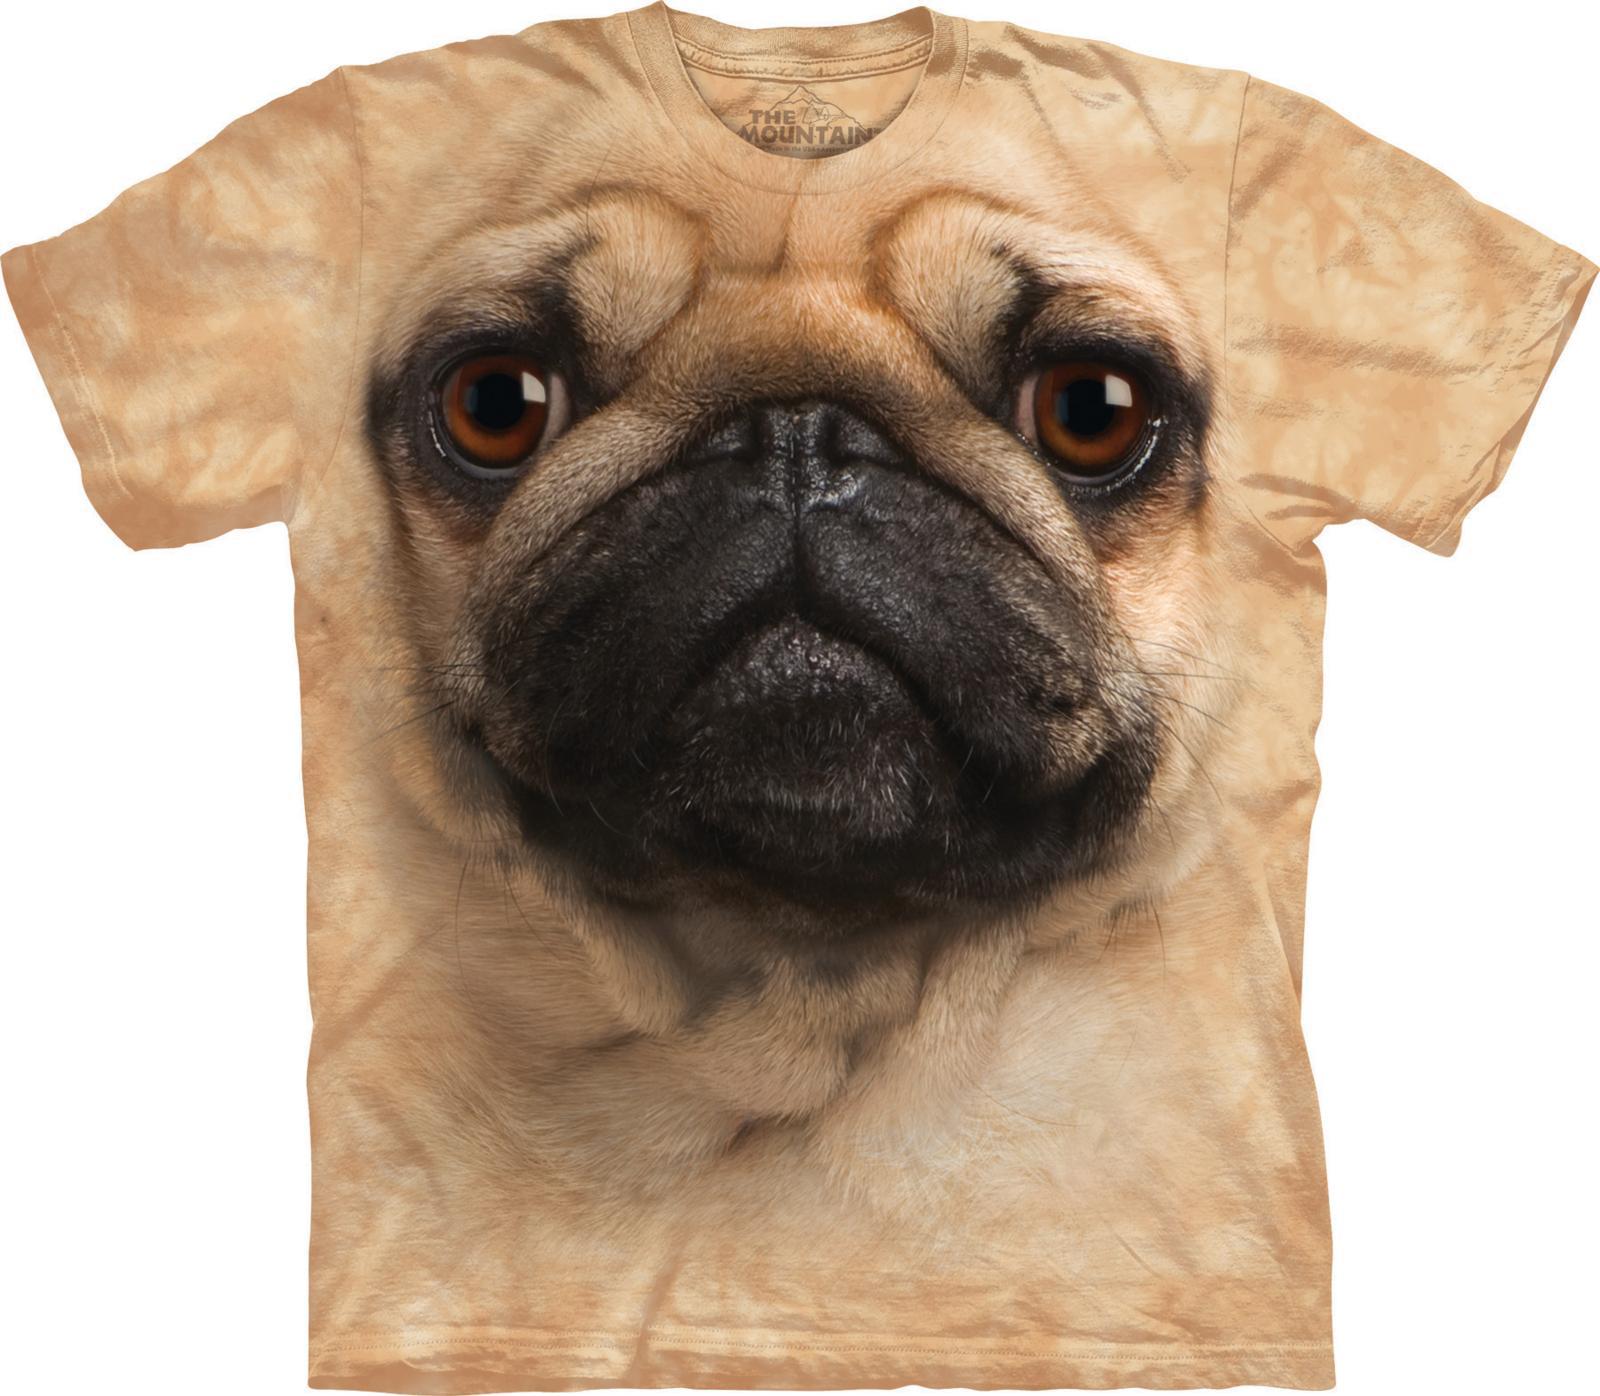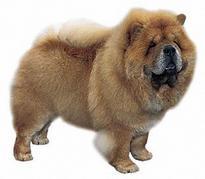The first image is the image on the left, the second image is the image on the right. For the images displayed, is the sentence "One of the images is not a living creature." factually correct? Answer yes or no. Yes. 